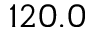Convert formula to latex. <formula><loc_0><loc_0><loc_500><loc_500>1 2 0 . 0</formula> 